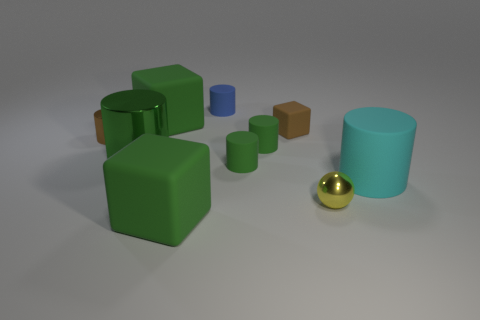Subtract all red cubes. How many green cylinders are left? 3 Subtract 3 cylinders. How many cylinders are left? 3 Subtract all brown cylinders. How many cylinders are left? 5 Subtract all metallic cylinders. How many cylinders are left? 4 Subtract all brown cylinders. Subtract all brown spheres. How many cylinders are left? 5 Subtract all balls. How many objects are left? 9 Subtract 0 gray cylinders. How many objects are left? 10 Subtract all small brown balls. Subtract all large cyan things. How many objects are left? 9 Add 1 large green matte objects. How many large green matte objects are left? 3 Add 8 tiny yellow metal balls. How many tiny yellow metal balls exist? 9 